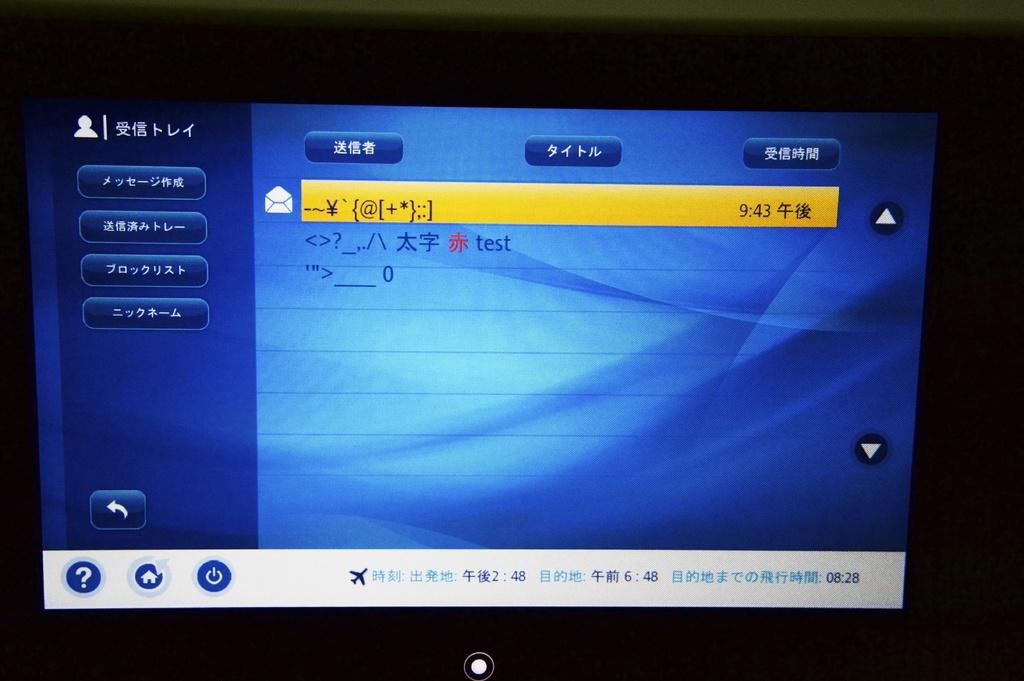<image>
Share a concise interpretation of the image provided. a screen with the time 2:48 at the bottom 